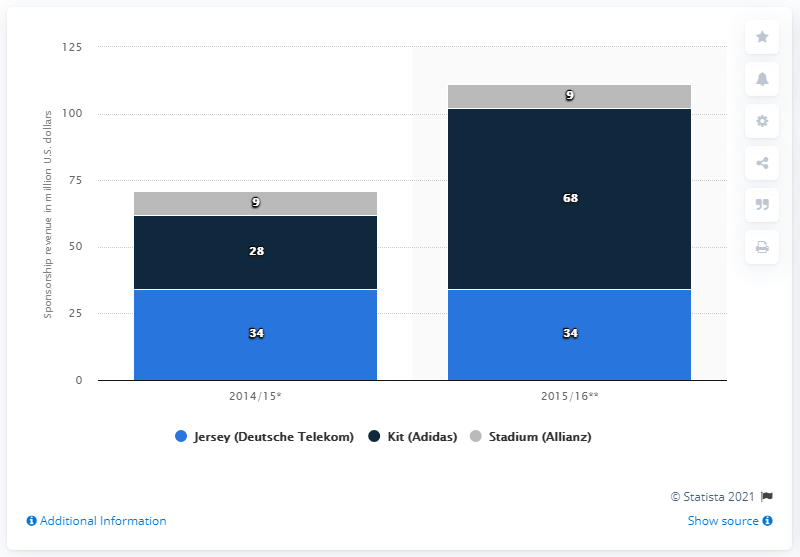Give some essential details in this illustration. The FC Bayern Munich generated a total of $28 million in kit sponsorship revenue during the 2014/15 season. 